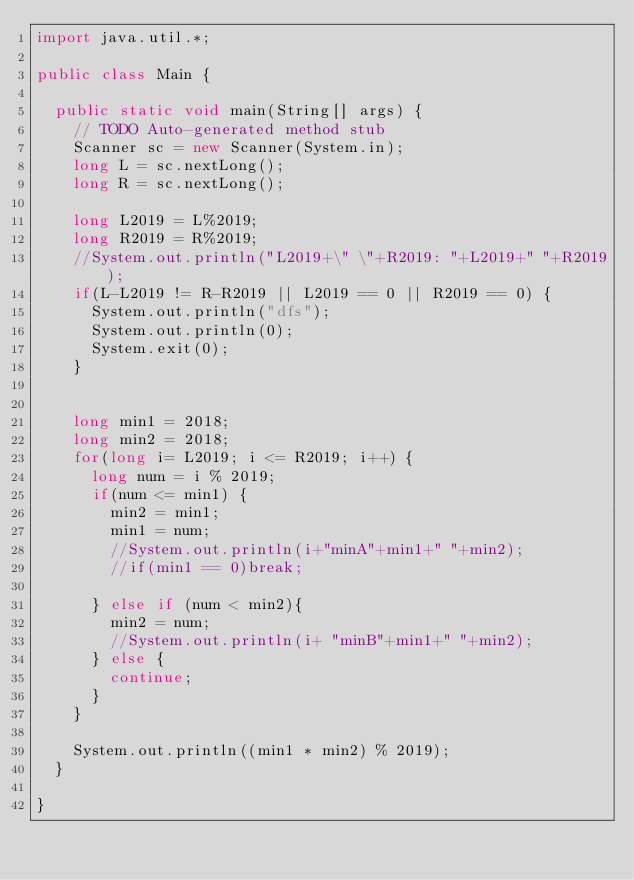Convert code to text. <code><loc_0><loc_0><loc_500><loc_500><_Java_>import java.util.*;

public class Main {

	public static void main(String[] args) {
		// TODO Auto-generated method stub
		Scanner sc = new Scanner(System.in);
		long L = sc.nextLong();
		long R = sc.nextLong();
		
		long L2019 = L%2019;
		long R2019 = R%2019;
		//System.out.println("L2019+\" \"+R2019: "+L2019+" "+R2019);
		if(L-L2019 != R-R2019 || L2019 == 0 || R2019 == 0) {
			System.out.println("dfs");
			System.out.println(0);
			System.exit(0);
		}
		
		
		long min1 = 2018;
		long min2 = 2018;
		for(long i= L2019; i <= R2019; i++) {
			long num = i % 2019;
			if(num <= min1) {
				min2 = min1;
				min1 = num;
				//System.out.println(i+"minA"+min1+" "+min2);
				//if(min1 == 0)break;
				
			} else if (num < min2){
				min2 = num;
				//System.out.println(i+ "minB"+min1+" "+min2);
			} else {
				continue;
			}
		}
		
		System.out.println((min1 * min2) % 2019);
	}

}
</code> 